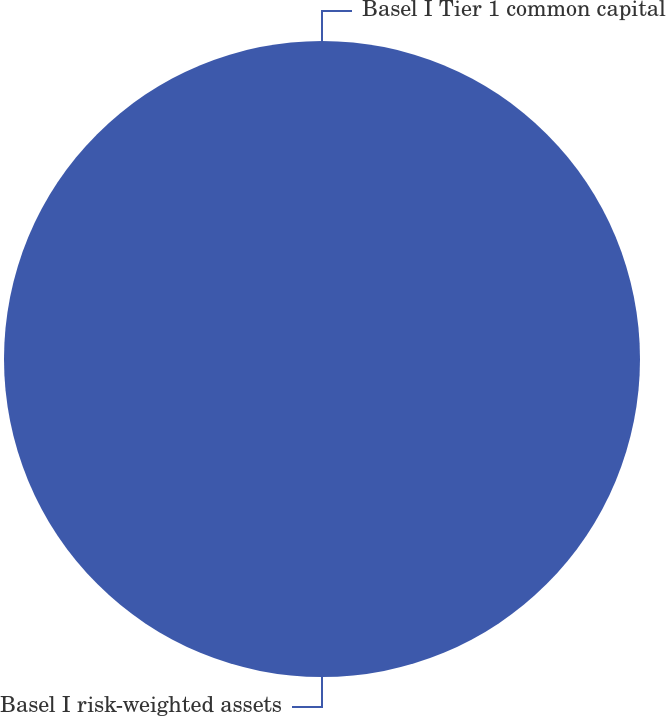Convert chart to OTSL. <chart><loc_0><loc_0><loc_500><loc_500><pie_chart><fcel>Basel I risk-weighted assets<fcel>Basel I Tier 1 common capital<nl><fcel>100.0%<fcel>0.0%<nl></chart> 